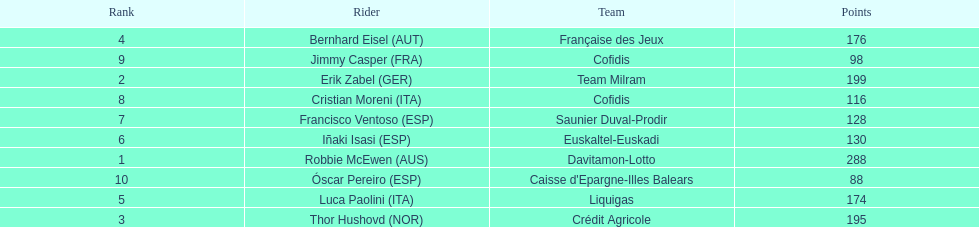How many points did robbie mcewen and cristian moreni score together? 404. 